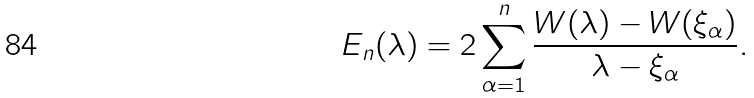Convert formula to latex. <formula><loc_0><loc_0><loc_500><loc_500>E _ { n } ( \lambda ) = 2 \sum _ { \alpha = 1 } ^ { n } \frac { W ( \lambda ) - W ( \xi _ { \alpha } ) } { \lambda - \xi _ { \alpha } } .</formula> 